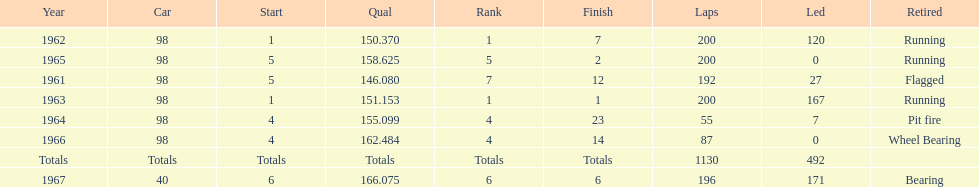How many consecutive years did parnelli place in the top 5? 5. 